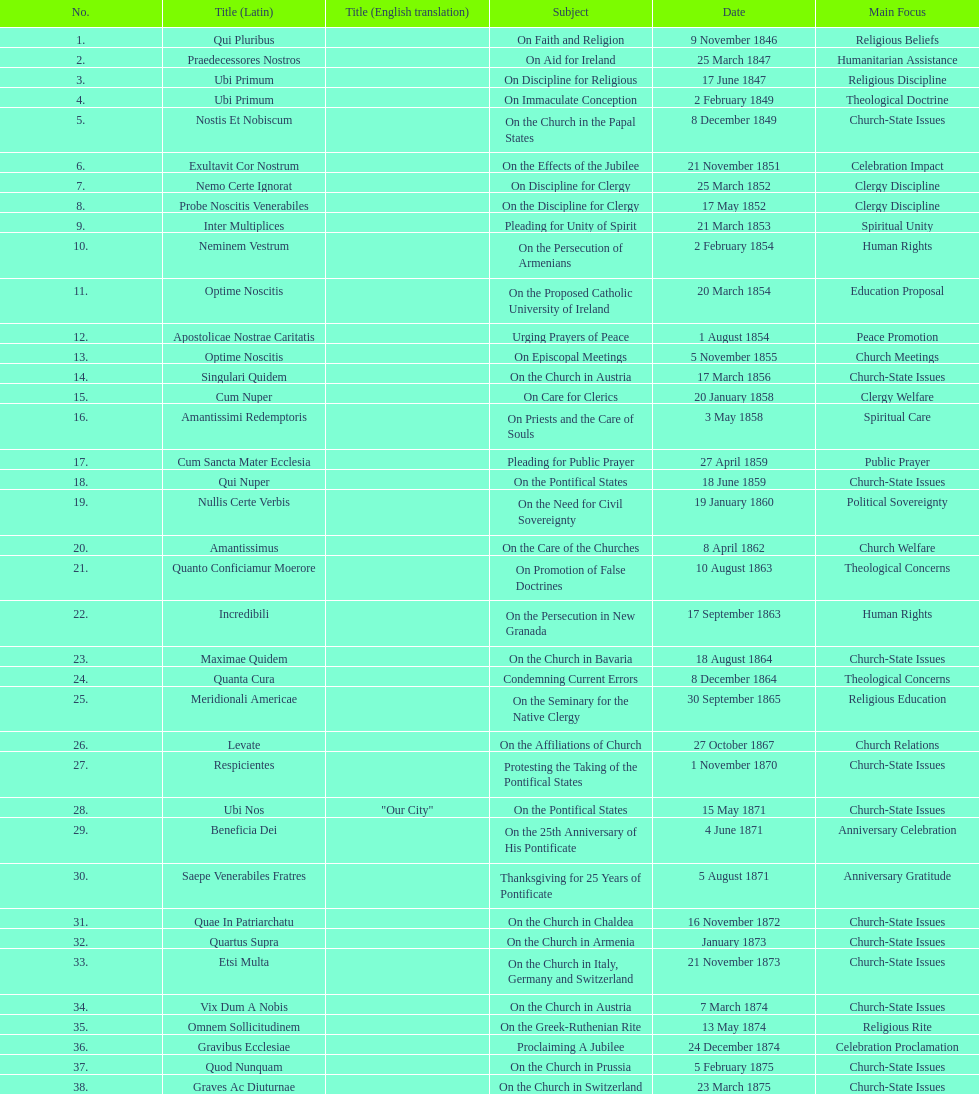How many subjects are there? 38. 